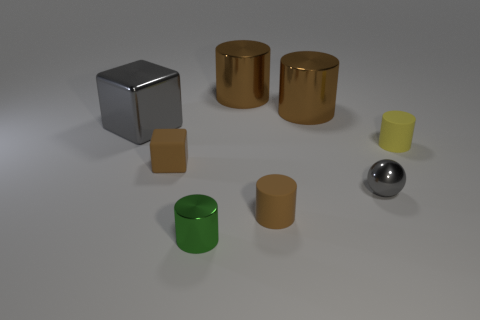Subtract all red blocks. How many brown cylinders are left? 3 Subtract all green cylinders. How many cylinders are left? 4 Subtract all small yellow cylinders. How many cylinders are left? 4 Subtract 1 cylinders. How many cylinders are left? 4 Add 1 small cyan spheres. How many objects exist? 9 Subtract all yellow cylinders. Subtract all red cubes. How many cylinders are left? 4 Subtract all cylinders. How many objects are left? 3 Subtract 1 gray spheres. How many objects are left? 7 Subtract all big red shiny spheres. Subtract all big gray things. How many objects are left? 7 Add 5 brown matte objects. How many brown matte objects are left? 7 